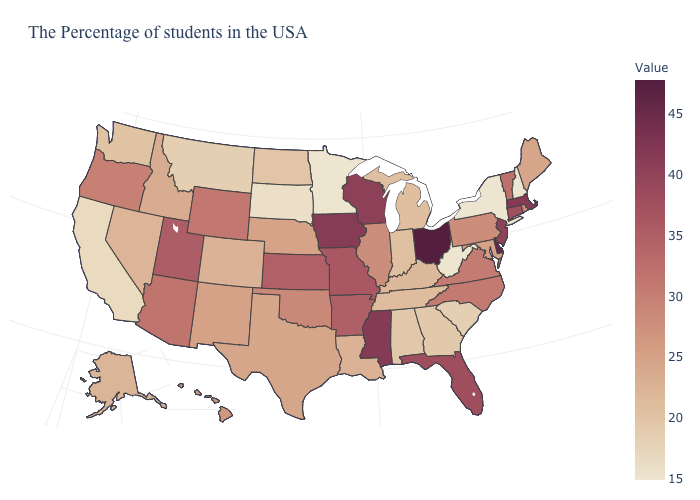Does New York have the lowest value in the USA?
Be succinct. Yes. Among the states that border Nevada , does California have the lowest value?
Keep it brief. Yes. Among the states that border Colorado , does Nebraska have the lowest value?
Quick response, please. Yes. Which states hav the highest value in the Northeast?
Be succinct. Massachusetts. Among the states that border Kentucky , does West Virginia have the lowest value?
Short answer required. Yes. Does West Virginia have the lowest value in the USA?
Quick response, please. Yes. 